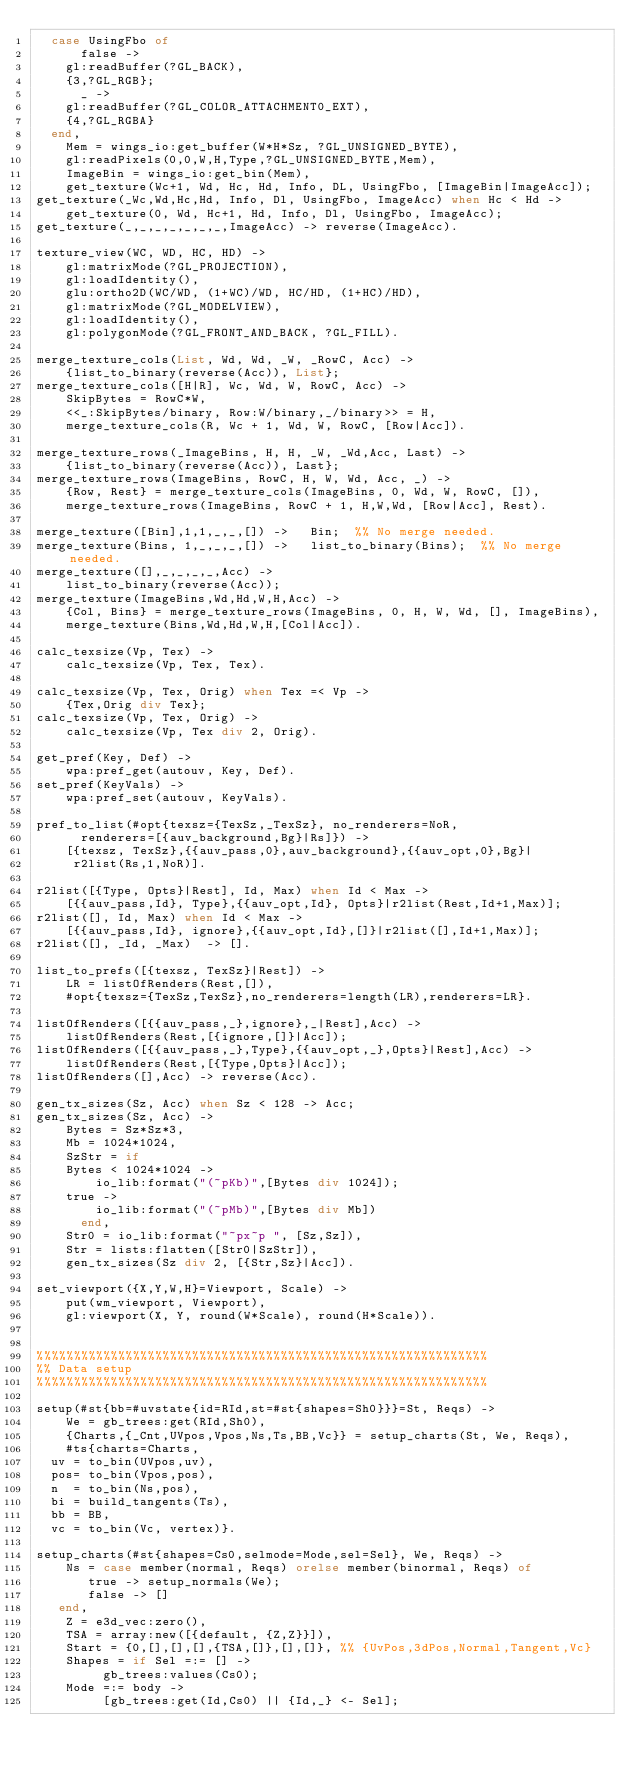<code> <loc_0><loc_0><loc_500><loc_500><_Erlang_>	case UsingFbo of
	    false -> 
		gl:readBuffer(?GL_BACK),
		{3,?GL_RGB};
	    _ -> 
		gl:readBuffer(?GL_COLOR_ATTACHMENT0_EXT),
		{4,?GL_RGBA}
	end,
    Mem = wings_io:get_buffer(W*H*Sz, ?GL_UNSIGNED_BYTE),
    gl:readPixels(0,0,W,H,Type,?GL_UNSIGNED_BYTE,Mem),
    ImageBin = wings_io:get_bin(Mem),
    get_texture(Wc+1, Wd, Hc, Hd, Info, DL, UsingFbo, [ImageBin|ImageAcc]);
get_texture(_Wc,Wd,Hc,Hd, Info, Dl, UsingFbo, ImageAcc) when Hc < Hd ->
    get_texture(0, Wd, Hc+1, Hd, Info, Dl, UsingFbo, ImageAcc);
get_texture(_,_,_,_,_,_,_,ImageAcc) -> reverse(ImageAcc).

texture_view(WC, WD, HC, HD) ->
    gl:matrixMode(?GL_PROJECTION),
    gl:loadIdentity(),
    glu:ortho2D(WC/WD, (1+WC)/WD, HC/HD, (1+HC)/HD),
    gl:matrixMode(?GL_MODELVIEW),
    gl:loadIdentity(),
    gl:polygonMode(?GL_FRONT_AND_BACK, ?GL_FILL).
    
merge_texture_cols(List, Wd, Wd, _W, _RowC, Acc) ->
    {list_to_binary(reverse(Acc)), List};
merge_texture_cols([H|R], Wc, Wd, W, RowC, Acc) ->
    SkipBytes = RowC*W,
    <<_:SkipBytes/binary, Row:W/binary,_/binary>> = H,
    merge_texture_cols(R, Wc + 1, Wd, W, RowC, [Row|Acc]).

merge_texture_rows(_ImageBins, H, H, _W, _Wd,Acc, Last) ->
    {list_to_binary(reverse(Acc)), Last};
merge_texture_rows(ImageBins, RowC, H, W, Wd, Acc, _) ->
    {Row, Rest} = merge_texture_cols(ImageBins, 0, Wd, W, RowC, []),
    merge_texture_rows(ImageBins, RowC + 1, H,W,Wd, [Row|Acc], Rest).

merge_texture([Bin],1,1,_,_,[]) ->   Bin;  %% No merge needed.
merge_texture(Bins, 1,_,_,_,[]) ->   list_to_binary(Bins);  %% No merge needed.
merge_texture([],_,_,_,_,Acc) -> 
    list_to_binary(reverse(Acc));
merge_texture(ImageBins,Wd,Hd,W,H,Acc) ->    
    {Col, Bins} = merge_texture_rows(ImageBins, 0, H, W, Wd, [], ImageBins),
    merge_texture(Bins,Wd,Hd,W,H,[Col|Acc]).

calc_texsize(Vp, Tex) ->
    calc_texsize(Vp, Tex, Tex).

calc_texsize(Vp, Tex, Orig) when Tex =< Vp ->
    {Tex,Orig div Tex};
calc_texsize(Vp, Tex, Orig) ->
    calc_texsize(Vp, Tex div 2, Orig).

get_pref(Key, Def) ->
    wpa:pref_get(autouv, Key, Def).
set_pref(KeyVals) ->
    wpa:pref_set(autouv, KeyVals).

pref_to_list(#opt{texsz={TexSz,_TexSz}, no_renderers=NoR, 
		  renderers=[{auv_background,Bg}|Rs]}) ->
    [{texsz, TexSz},{{auv_pass,0},auv_background},{{auv_opt,0},Bg}|
     r2list(Rs,1,NoR)].

r2list([{Type, Opts}|Rest], Id, Max) when Id < Max ->
    [{{auv_pass,Id}, Type},{{auv_opt,Id}, Opts}|r2list(Rest,Id+1,Max)];
r2list([], Id, Max) when Id < Max ->
    [{{auv_pass,Id}, ignore},{{auv_opt,Id},[]}|r2list([],Id+1,Max)];
r2list([], _Id, _Max)  -> [].

list_to_prefs([{texsz, TexSz}|Rest]) ->
    LR = listOfRenders(Rest,[]),
    #opt{texsz={TexSz,TexSz},no_renderers=length(LR),renderers=LR}.

listOfRenders([{{auv_pass,_},ignore},_|Rest],Acc) ->
    listOfRenders(Rest,[{ignore,[]}|Acc]);
listOfRenders([{{auv_pass,_},Type},{{auv_opt,_},Opts}|Rest],Acc) ->
    listOfRenders(Rest,[{Type,Opts}|Acc]);
listOfRenders([],Acc) -> reverse(Acc).
    
gen_tx_sizes(Sz, Acc) when Sz < 128 -> Acc;
gen_tx_sizes(Sz, Acc) ->
    Bytes = Sz*Sz*3,
    Mb = 1024*1024,
    SzStr = if
		Bytes < 1024*1024 ->
		    io_lib:format("(~pKb)",[Bytes div 1024]);
		true ->
		    io_lib:format("(~pMb)",[Bytes div Mb])
	    end,
    Str0 = io_lib:format("~px~p ", [Sz,Sz]),
    Str = lists:flatten([Str0|SzStr]),
    gen_tx_sizes(Sz div 2, [{Str,Sz}|Acc]).

set_viewport({X,Y,W,H}=Viewport, Scale) ->
    put(wm_viewport, Viewport),
    gl:viewport(X, Y, round(W*Scale), round(H*Scale)).


%%%%%%%%%%%%%%%%%%%%%%%%%%%%%%%%%%%%%%%%%%%%%%%%%%%%%%%%%%%%%
%% Data setup 
%%%%%%%%%%%%%%%%%%%%%%%%%%%%%%%%%%%%%%%%%%%%%%%%%%%%%%%%%%%%%

setup(#st{bb=#uvstate{id=RId,st=#st{shapes=Sh0}}}=St, Reqs) ->
    We = gb_trees:get(RId,Sh0),
    {Charts,{_Cnt,UVpos,Vpos,Ns,Ts,BB,Vc}} = setup_charts(St, We, Reqs),
    #ts{charts=Charts,
	uv = to_bin(UVpos,uv),
	pos= to_bin(Vpos,pos),
	n  = to_bin(Ns,pos),
	bi = build_tangents(Ts),
	bb = BB,
	vc = to_bin(Vc, vertex)}.

setup_charts(#st{shapes=Cs0,selmode=Mode,sel=Sel}, We, Reqs) ->
    Ns = case member(normal, Reqs) orelse member(binormal, Reqs) of
	     true -> setup_normals(We);
	     false -> []
	 end,
    Z = e3d_vec:zero(),
    TSA = array:new([{default, {Z,Z}}]),
    Start = {0,[],[],[],{TSA,[]},[],[]}, %% {UvPos,3dPos,Normal,Tangent,Vc}
    Shapes = if Sel =:= [] -> 
		     gb_trees:values(Cs0);
		Mode =:= body -> 
		     [gb_trees:get(Id,Cs0) || {Id,_} <- Sel];</code> 